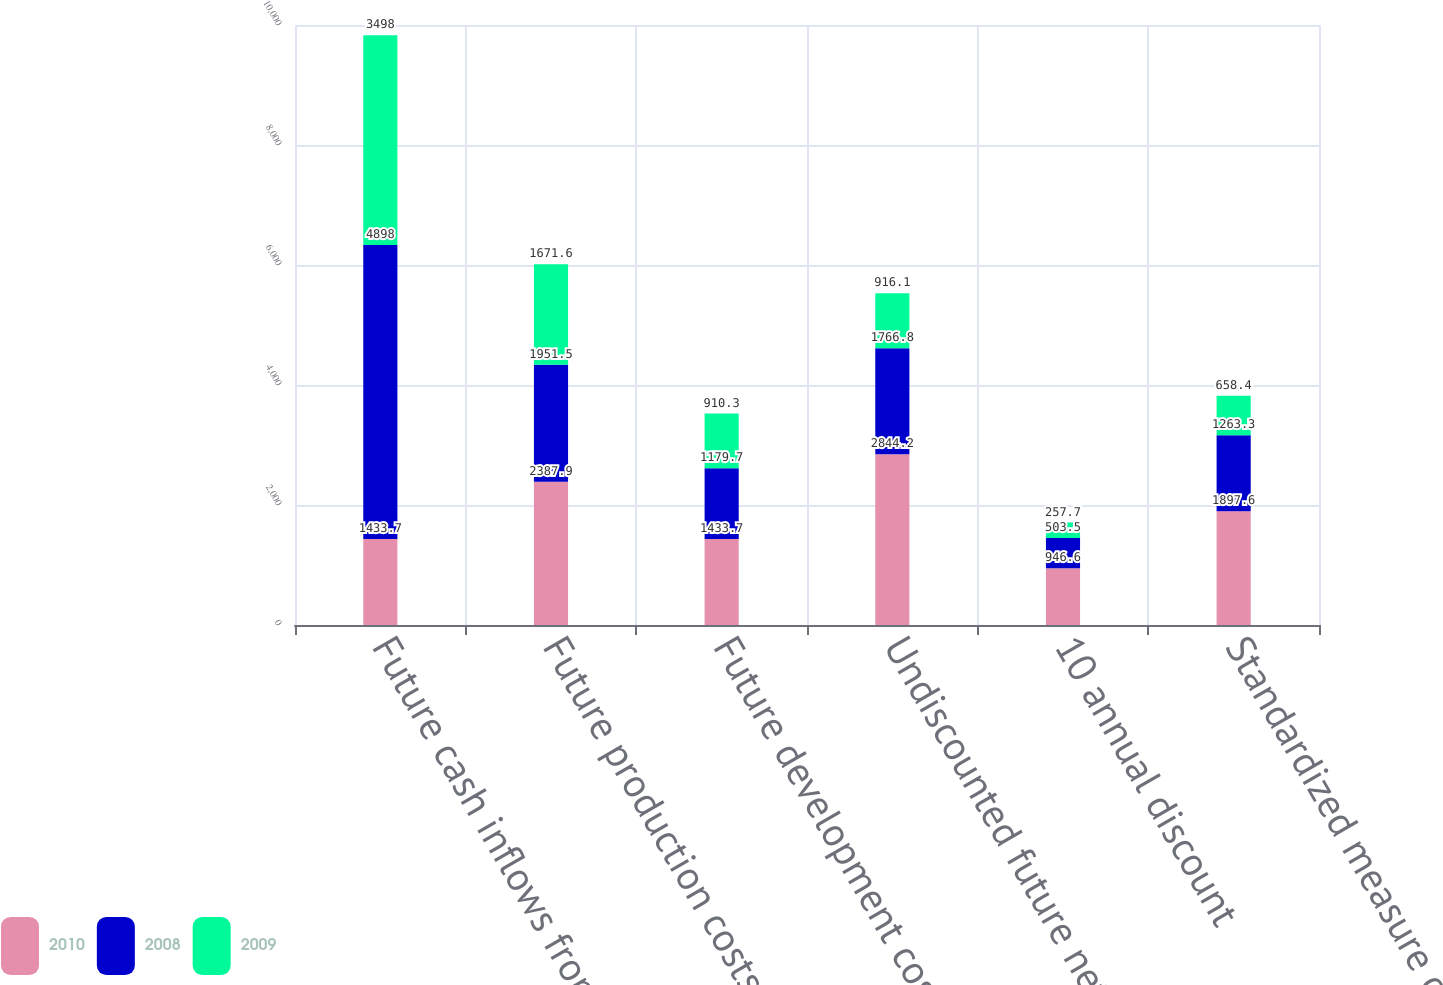Convert chart. <chart><loc_0><loc_0><loc_500><loc_500><stacked_bar_chart><ecel><fcel>Future cash inflows from<fcel>Future production costs<fcel>Future development costs(b)<fcel>Undiscounted future net cash<fcel>10 annual discount<fcel>Standardized measure of<nl><fcel>2010<fcel>1433.7<fcel>2387.9<fcel>1433.7<fcel>2844.2<fcel>946.6<fcel>1897.6<nl><fcel>2008<fcel>4898<fcel>1951.5<fcel>1179.7<fcel>1766.8<fcel>503.5<fcel>1263.3<nl><fcel>2009<fcel>3498<fcel>1671.6<fcel>910.3<fcel>916.1<fcel>257.7<fcel>658.4<nl></chart> 